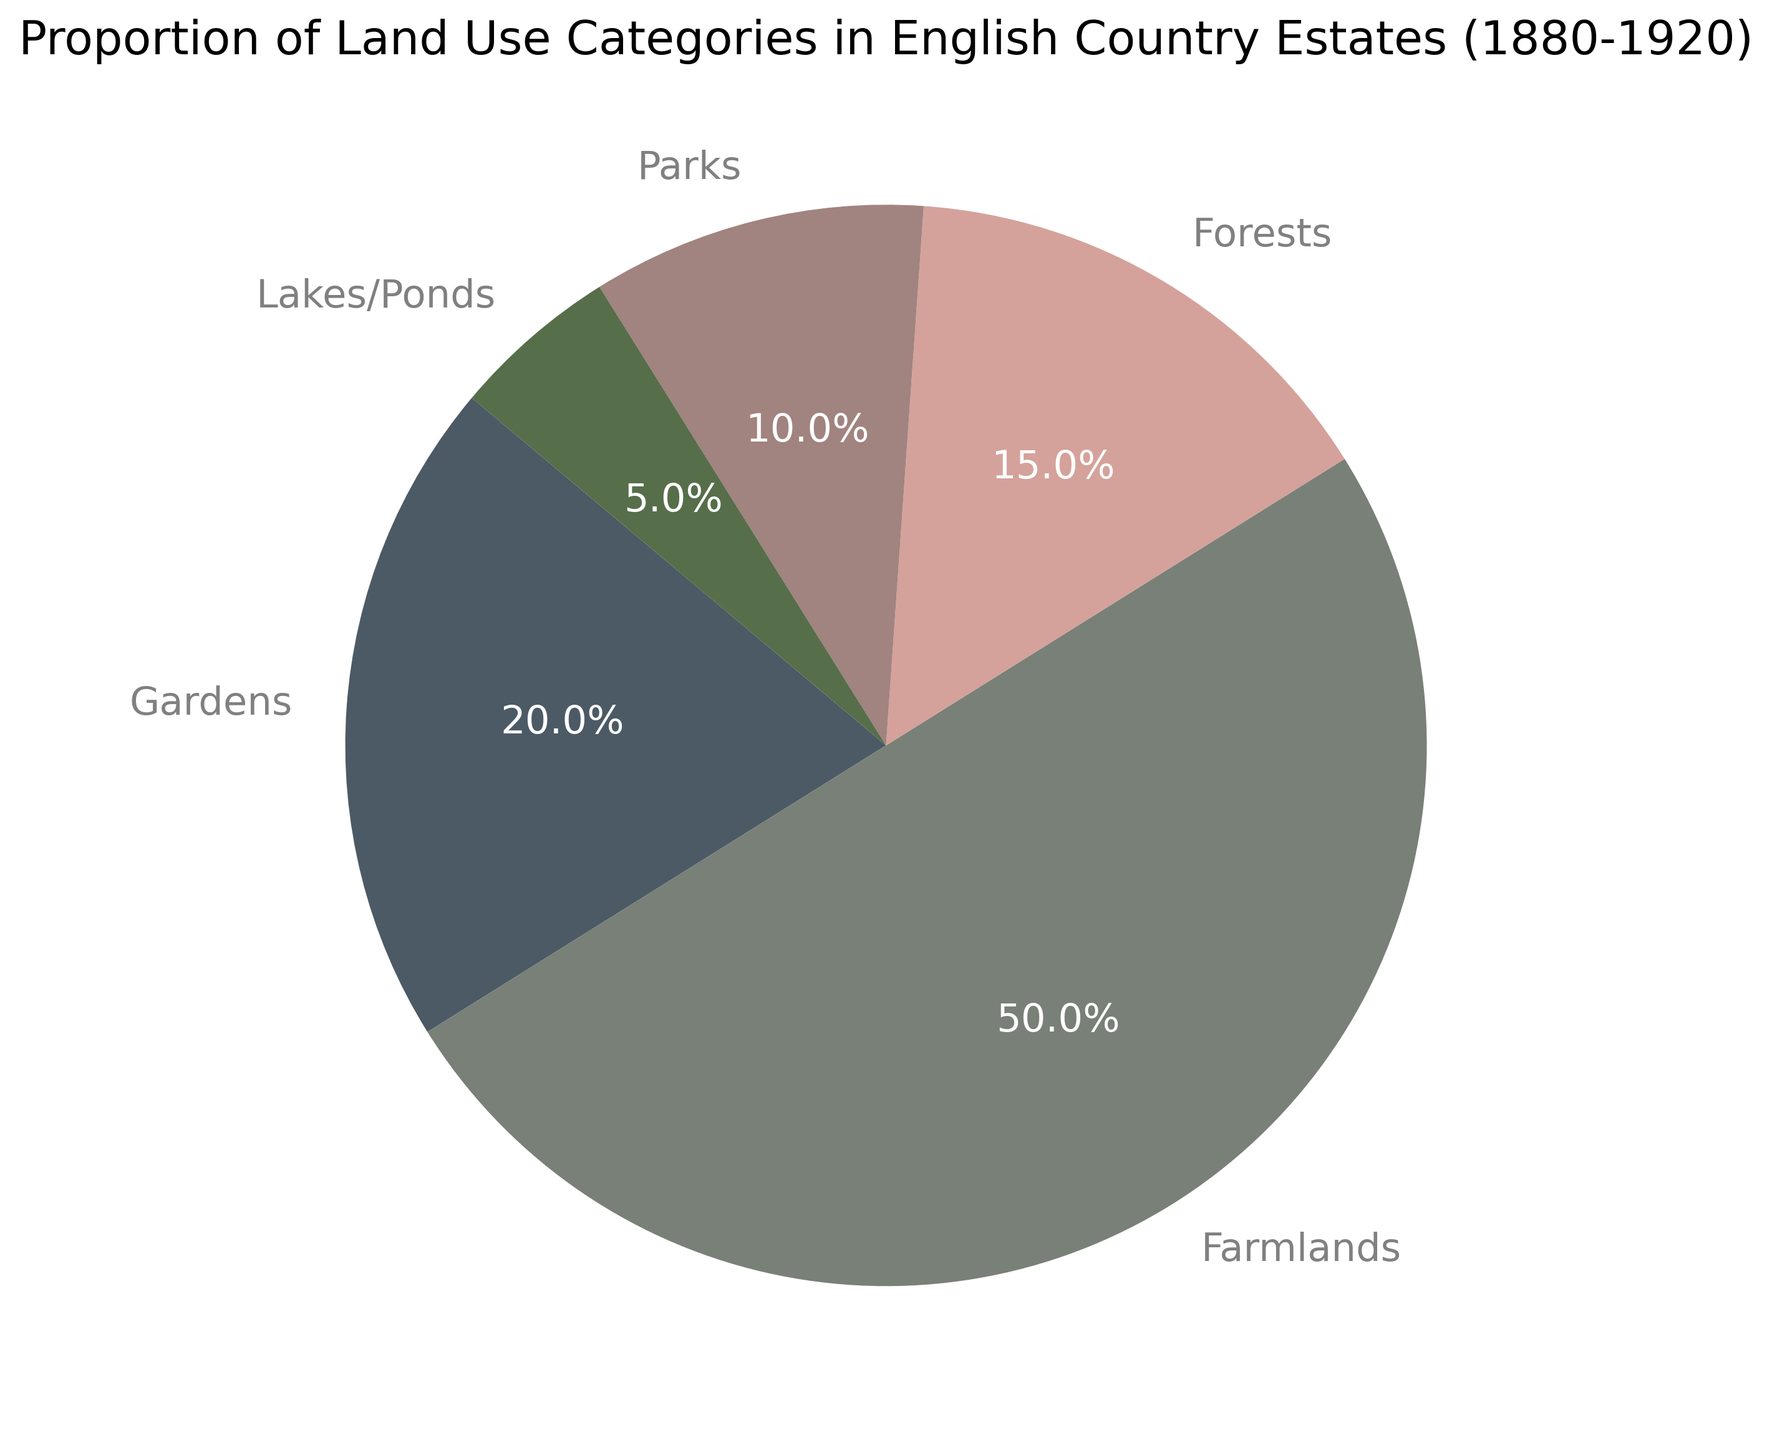What category occupies the largest proportion of land use? The pie chart shows the largest segment belongs to Farmlands, which is 50%.
Answer: Farmlands (50%) Which two categories combined occupy more than half of the land use? Adding the proportions of Farmlands (50%) and Gardens (20%), we get 70%, which is more than 50%.
Answer: Farmlands, Gardens How much more land proportion does Forests cover compared to Lakes/Ponds? By subtracting the proportion of Lakes/Ponds (5%) from that of Forests (15%), we get 10%.
Answer: 10% What is the combined proportion of Parks and Lakes/Ponds? Adding the proportions of Parks (10%) and Lakes/Ponds (5%), we get 15%.
Answer: 15% Which land use category is represented by the color red? By examining the color legend, we see that none of the categories is represented by the color red.
Answer: None What percentage of land use is not occupied by Farmlands? Subtracting the proportion of Farmlands (50%) from 100%, we get 50%.
Answer: 50% If another estate only had Gardens and Forests, what would be the average proportion of land use per category in that estate? Adding the proportions of Gardens (20%) and Forests (15%) gives 35%, dividing by 2 categories, the average is 17.5%.
Answer: 17.5% Which category covers the second largest proportion of land? The second largest segment after Farmlands (50%) is Gardens (20%).
Answer: Gardens (20%) If Gardens increased by 10%, how would that affect the total proportion of the land use? Adding 10% to Gardens’ current proportion (20%) would increase it to 30%, making the new total 110%.
Answer: 110% How many times larger is the proportion of Farmlands compared to Lakes/Ponds? Dividing the proportion of Farmlands (50%) by that of Lakes/Ponds (5%) gives 10 times larger.
Answer: 10 times 